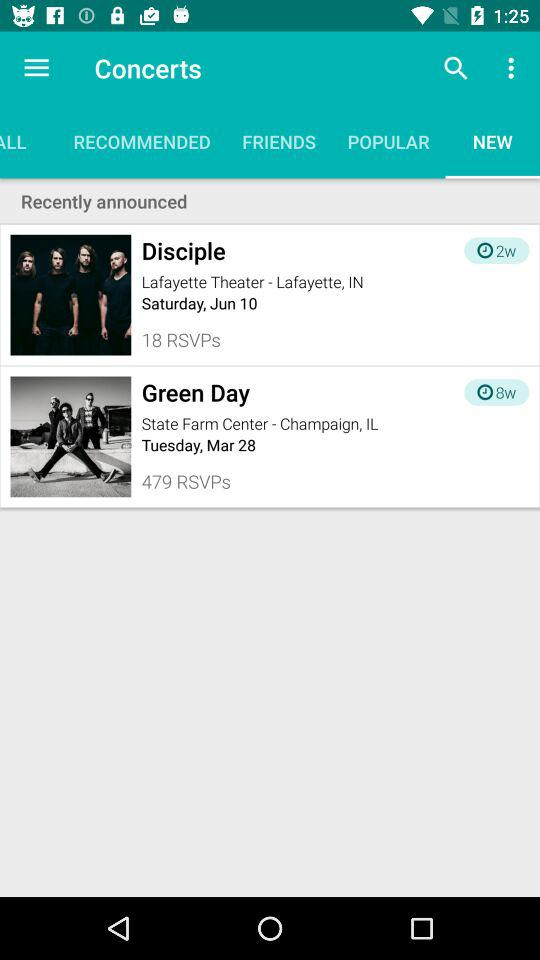How many more RSVPs does the event with Green Day have than the event with Disciple?
Answer the question using a single word or phrase. 461 